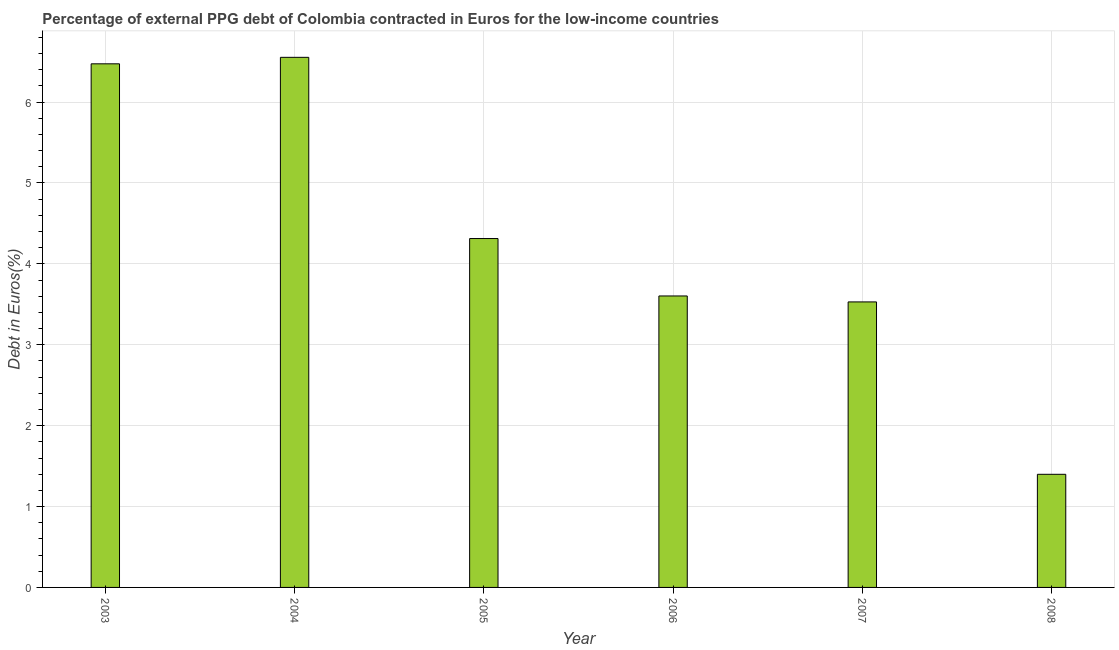Does the graph contain grids?
Give a very brief answer. Yes. What is the title of the graph?
Give a very brief answer. Percentage of external PPG debt of Colombia contracted in Euros for the low-income countries. What is the label or title of the X-axis?
Provide a short and direct response. Year. What is the label or title of the Y-axis?
Make the answer very short. Debt in Euros(%). What is the currency composition of ppg debt in 2005?
Keep it short and to the point. 4.31. Across all years, what is the maximum currency composition of ppg debt?
Make the answer very short. 6.55. Across all years, what is the minimum currency composition of ppg debt?
Your answer should be very brief. 1.4. In which year was the currency composition of ppg debt maximum?
Ensure brevity in your answer.  2004. In which year was the currency composition of ppg debt minimum?
Your answer should be very brief. 2008. What is the sum of the currency composition of ppg debt?
Provide a succinct answer. 25.87. What is the difference between the currency composition of ppg debt in 2003 and 2005?
Provide a succinct answer. 2.16. What is the average currency composition of ppg debt per year?
Your response must be concise. 4.31. What is the median currency composition of ppg debt?
Provide a short and direct response. 3.96. What is the ratio of the currency composition of ppg debt in 2003 to that in 2005?
Your response must be concise. 1.5. Is the currency composition of ppg debt in 2005 less than that in 2008?
Your answer should be compact. No. Is the difference between the currency composition of ppg debt in 2004 and 2006 greater than the difference between any two years?
Keep it short and to the point. No. What is the difference between the highest and the second highest currency composition of ppg debt?
Your answer should be compact. 0.08. Is the sum of the currency composition of ppg debt in 2004 and 2008 greater than the maximum currency composition of ppg debt across all years?
Offer a terse response. Yes. What is the difference between the highest and the lowest currency composition of ppg debt?
Make the answer very short. 5.16. How many years are there in the graph?
Offer a terse response. 6. What is the difference between two consecutive major ticks on the Y-axis?
Your response must be concise. 1. What is the Debt in Euros(%) of 2003?
Your response must be concise. 6.47. What is the Debt in Euros(%) in 2004?
Your answer should be very brief. 6.55. What is the Debt in Euros(%) in 2005?
Give a very brief answer. 4.31. What is the Debt in Euros(%) in 2006?
Your answer should be compact. 3.6. What is the Debt in Euros(%) in 2007?
Your response must be concise. 3.53. What is the Debt in Euros(%) of 2008?
Provide a succinct answer. 1.4. What is the difference between the Debt in Euros(%) in 2003 and 2004?
Keep it short and to the point. -0.08. What is the difference between the Debt in Euros(%) in 2003 and 2005?
Provide a succinct answer. 2.16. What is the difference between the Debt in Euros(%) in 2003 and 2006?
Your response must be concise. 2.87. What is the difference between the Debt in Euros(%) in 2003 and 2007?
Provide a short and direct response. 2.94. What is the difference between the Debt in Euros(%) in 2003 and 2008?
Ensure brevity in your answer.  5.07. What is the difference between the Debt in Euros(%) in 2004 and 2005?
Offer a terse response. 2.24. What is the difference between the Debt in Euros(%) in 2004 and 2006?
Provide a short and direct response. 2.95. What is the difference between the Debt in Euros(%) in 2004 and 2007?
Your answer should be very brief. 3.02. What is the difference between the Debt in Euros(%) in 2004 and 2008?
Your response must be concise. 5.16. What is the difference between the Debt in Euros(%) in 2005 and 2006?
Ensure brevity in your answer.  0.71. What is the difference between the Debt in Euros(%) in 2005 and 2007?
Make the answer very short. 0.78. What is the difference between the Debt in Euros(%) in 2005 and 2008?
Keep it short and to the point. 2.91. What is the difference between the Debt in Euros(%) in 2006 and 2007?
Provide a succinct answer. 0.07. What is the difference between the Debt in Euros(%) in 2006 and 2008?
Offer a very short reply. 2.2. What is the difference between the Debt in Euros(%) in 2007 and 2008?
Make the answer very short. 2.13. What is the ratio of the Debt in Euros(%) in 2003 to that in 2004?
Your answer should be very brief. 0.99. What is the ratio of the Debt in Euros(%) in 2003 to that in 2005?
Make the answer very short. 1.5. What is the ratio of the Debt in Euros(%) in 2003 to that in 2006?
Provide a succinct answer. 1.8. What is the ratio of the Debt in Euros(%) in 2003 to that in 2007?
Offer a terse response. 1.83. What is the ratio of the Debt in Euros(%) in 2003 to that in 2008?
Keep it short and to the point. 4.63. What is the ratio of the Debt in Euros(%) in 2004 to that in 2005?
Your answer should be very brief. 1.52. What is the ratio of the Debt in Euros(%) in 2004 to that in 2006?
Offer a very short reply. 1.82. What is the ratio of the Debt in Euros(%) in 2004 to that in 2007?
Provide a short and direct response. 1.86. What is the ratio of the Debt in Euros(%) in 2004 to that in 2008?
Keep it short and to the point. 4.69. What is the ratio of the Debt in Euros(%) in 2005 to that in 2006?
Offer a terse response. 1.2. What is the ratio of the Debt in Euros(%) in 2005 to that in 2007?
Offer a very short reply. 1.22. What is the ratio of the Debt in Euros(%) in 2005 to that in 2008?
Ensure brevity in your answer.  3.08. What is the ratio of the Debt in Euros(%) in 2006 to that in 2008?
Your answer should be very brief. 2.58. What is the ratio of the Debt in Euros(%) in 2007 to that in 2008?
Keep it short and to the point. 2.52. 